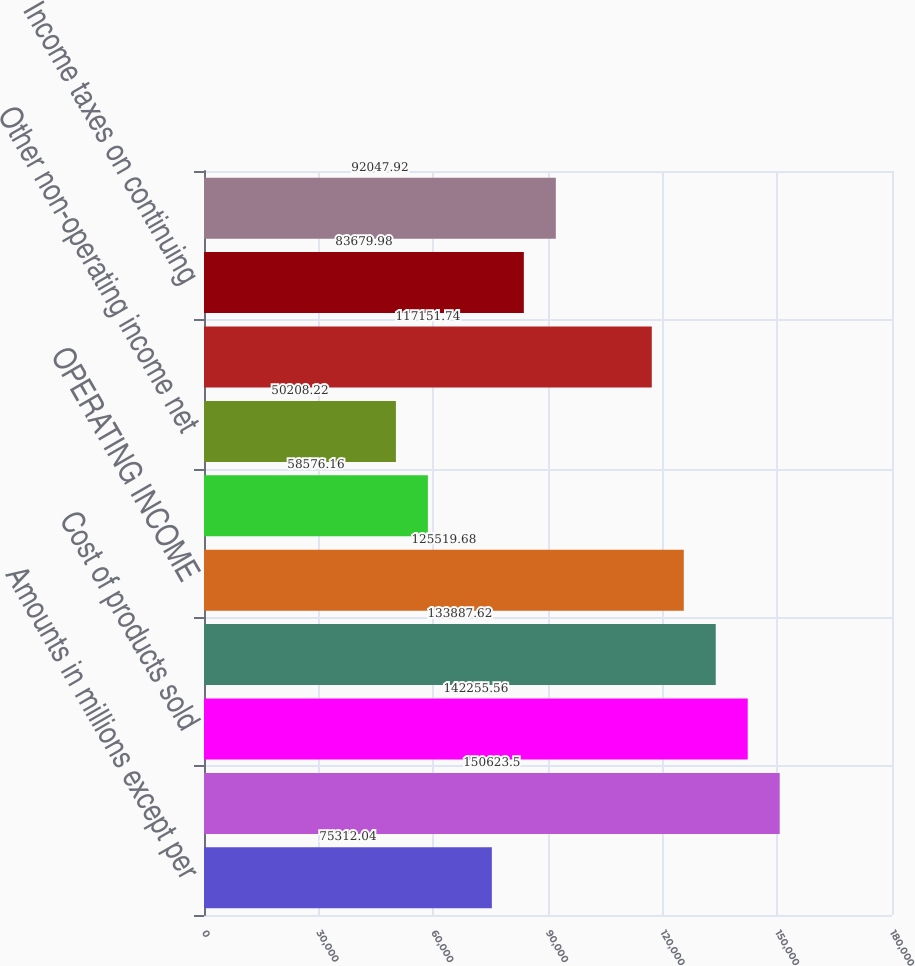<chart> <loc_0><loc_0><loc_500><loc_500><bar_chart><fcel>Amounts in millions except per<fcel>NET SALES<fcel>Cost of products sold<fcel>Selling general and<fcel>OPERATING INCOME<fcel>Interest expense<fcel>Other non-operating income net<fcel>EARNINGS FROM CONTINUING<fcel>Income taxes on continuing<fcel>NET EARNINGS FROM CONTINUING<nl><fcel>75312<fcel>150624<fcel>142256<fcel>133888<fcel>125520<fcel>58576.2<fcel>50208.2<fcel>117152<fcel>83680<fcel>92047.9<nl></chart> 